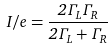Convert formula to latex. <formula><loc_0><loc_0><loc_500><loc_500>I / e = \frac { 2 \Gamma _ { L } \Gamma _ { R } } { 2 \Gamma _ { L } + \Gamma _ { R } }</formula> 